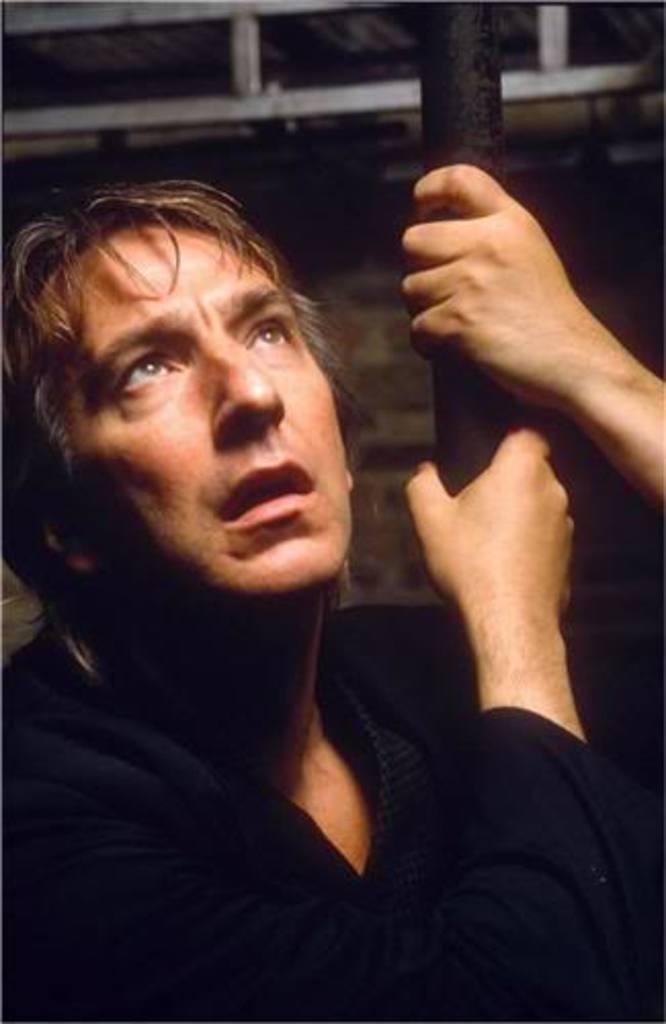Describe this image in one or two sentences. In this picture we can see a man holding a pole, in the background there is a wall. 